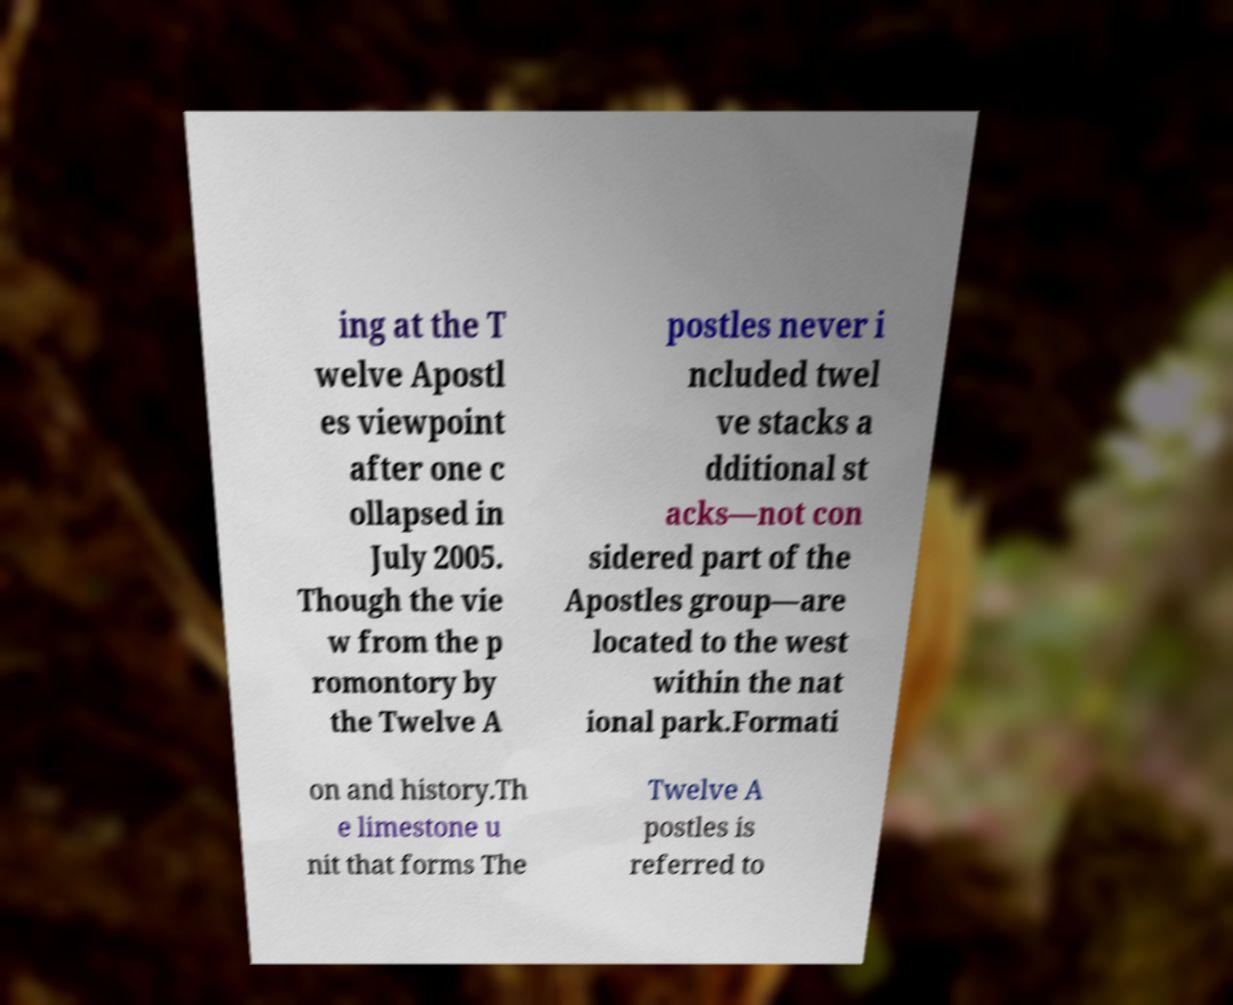There's text embedded in this image that I need extracted. Can you transcribe it verbatim? ing at the T welve Apostl es viewpoint after one c ollapsed in July 2005. Though the vie w from the p romontory by the Twelve A postles never i ncluded twel ve stacks a dditional st acks—not con sidered part of the Apostles group—are located to the west within the nat ional park.Formati on and history.Th e limestone u nit that forms The Twelve A postles is referred to 